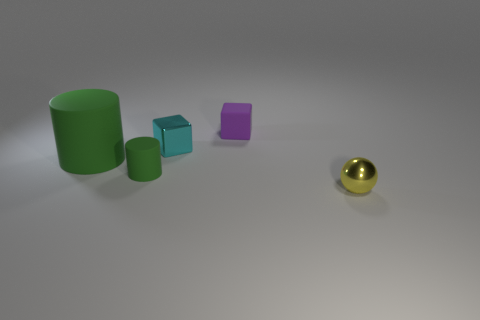Add 1 large purple cylinders. How many objects exist? 6 Subtract all cylinders. How many objects are left? 3 Subtract 1 cylinders. How many cylinders are left? 1 Subtract 0 red blocks. How many objects are left? 5 Subtract all brown spheres. Subtract all yellow blocks. How many spheres are left? 1 Subtract all cubes. Subtract all small matte cubes. How many objects are left? 2 Add 2 tiny matte objects. How many tiny matte objects are left? 4 Add 3 small cubes. How many small cubes exist? 5 